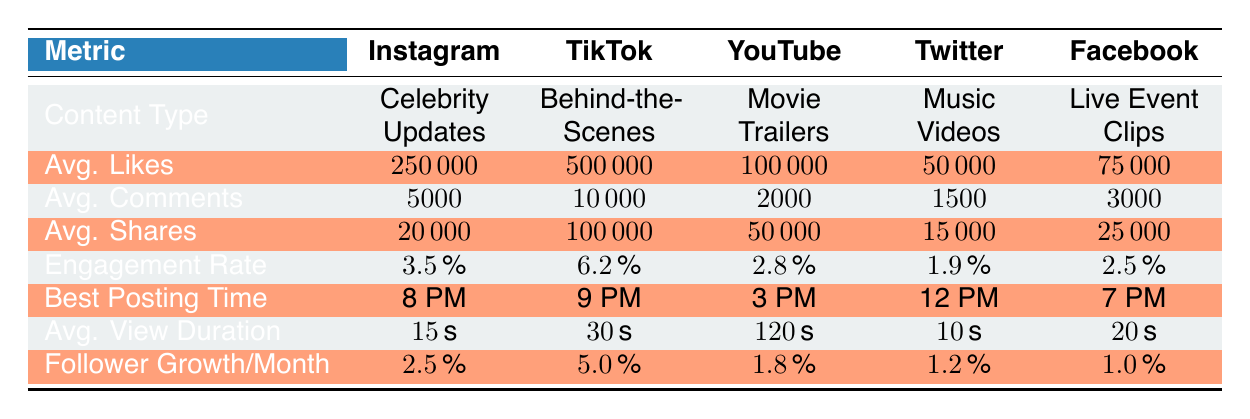What content type has the highest average likes per post? By looking at the "Avg. Likes" column, TikTok has the highest average likes per post at 500,000.
Answer: TikTok Which platform has the best engagement rate for behind-the-scenes content? The engagement rate for TikTok, which focuses on behind-the-scenes content, is 6.2%, the highest among the listed platforms.
Answer: TikTok Is the average number of comments on movie trailers higher than that on live event clips? The average number of comments for movie trailers is 2,000, whereas for live event clips it is 3,000. Since 2,000 is less than 3,000, the statement is false.
Answer: No What is the total average shares across all platforms? The average shares are summed as follows: 20,000 (Instagram) + 100,000 (TikTok) + 50,000 (YouTube) + 15,000 (Twitter) + 25,000 (Facebook) = 210,000.
Answer: 210,000 What is the average video view duration for the platform with the highest follower growth rate? The platform with the highest follower growth rate per month is TikTok at 5%. Its average video view duration is 30 seconds.
Answer: 30 seconds Does Facebook have a higher average likes per post compared to Twitter? Facebook's average likes per post is 75,000, while Twitter's is 50,000. Since 75,000 is greater than 50,000, the statement is true.
Answer: Yes Which content type has the lowest average likes per post? From the "Avg. Likes" column, music videos have the lowest average likes per post at 100,000.
Answer: Music Videos What is the difference in average comments between Instagram and TikTok? Instagram has 5,000 average comments, and TikTok has 10,000. The difference is 10,000 - 5,000 = 5,000.
Answer: 5,000 Which platform's best posting time is 12 PM? According to the "Best Posting Time" column, the best posting time at 12 PM corresponds to Twitter.
Answer: Twitter 